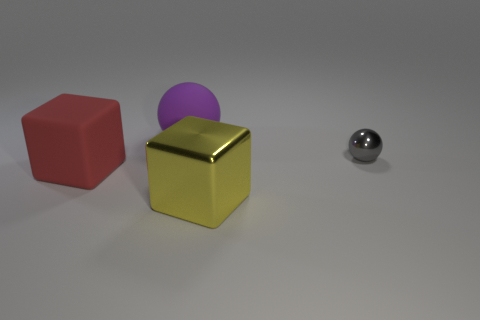Add 1 yellow metallic cubes. How many objects exist? 5 Subtract all gray balls. How many balls are left? 1 Add 1 large blue metal cylinders. How many large blue metal cylinders exist? 1 Subtract 0 purple cubes. How many objects are left? 4 Subtract all yellow blocks. Subtract all purple cylinders. How many blocks are left? 1 Subtract all big red rubber objects. Subtract all metallic cubes. How many objects are left? 2 Add 4 large balls. How many large balls are left? 5 